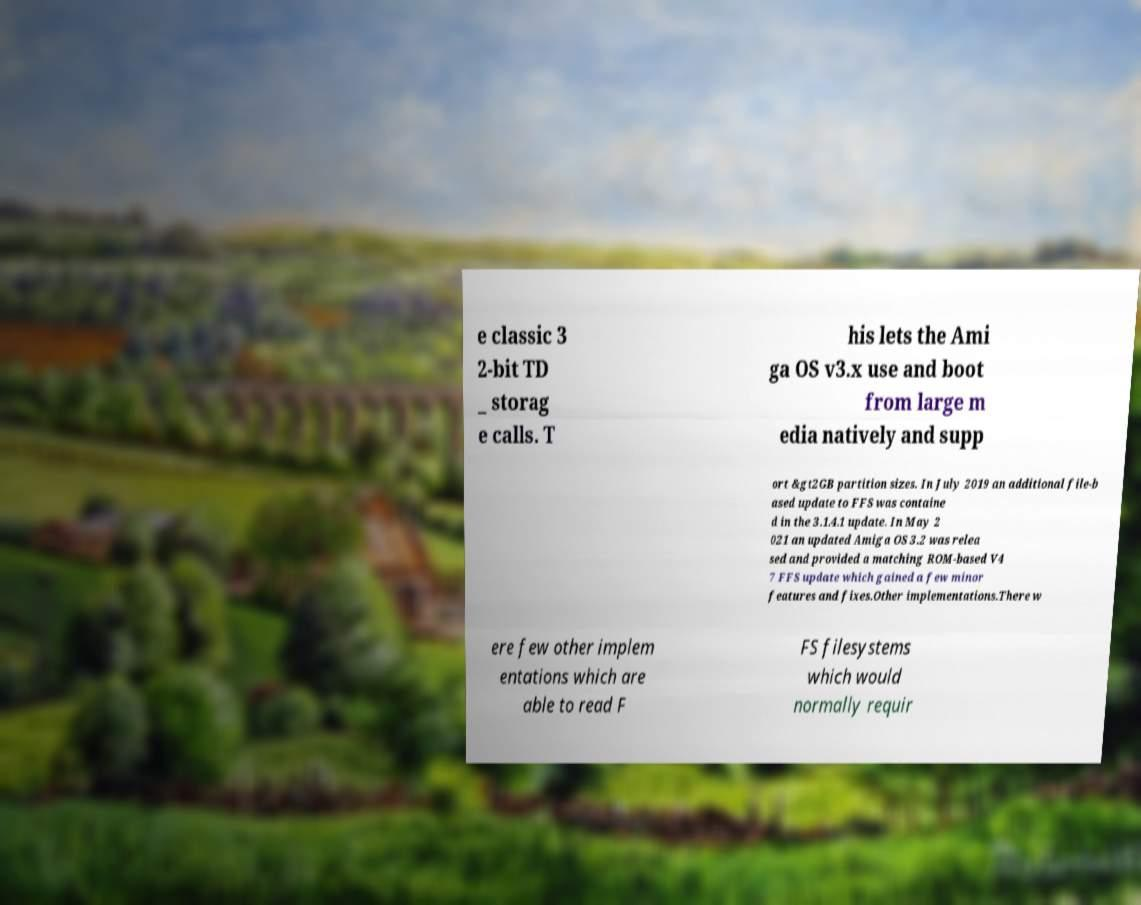Please identify and transcribe the text found in this image. e classic 3 2-bit TD _ storag e calls. T his lets the Ami ga OS v3.x use and boot from large m edia natively and supp ort &gt2GB partition sizes. In July 2019 an additional file-b ased update to FFS was containe d in the 3.1.4.1 update. In May 2 021 an updated Amiga OS 3.2 was relea sed and provided a matching ROM-based V4 7 FFS update which gained a few minor features and fixes.Other implementations.There w ere few other implem entations which are able to read F FS filesystems which would normally requir 